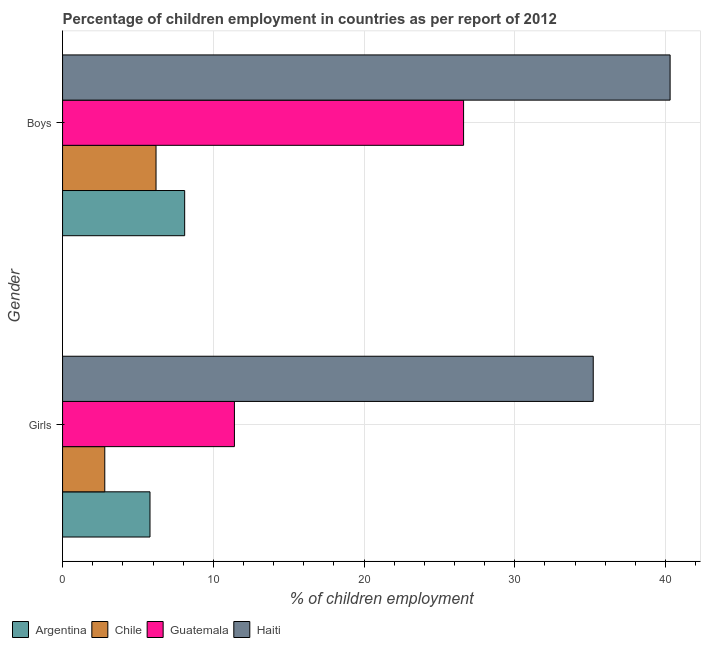How many groups of bars are there?
Make the answer very short. 2. Are the number of bars on each tick of the Y-axis equal?
Provide a succinct answer. Yes. How many bars are there on the 2nd tick from the top?
Your answer should be compact. 4. How many bars are there on the 1st tick from the bottom?
Make the answer very short. 4. What is the label of the 2nd group of bars from the top?
Keep it short and to the point. Girls. What is the percentage of employed girls in Chile?
Provide a succinct answer. 2.8. Across all countries, what is the maximum percentage of employed boys?
Offer a very short reply. 40.3. Across all countries, what is the minimum percentage of employed girls?
Your answer should be very brief. 2.8. In which country was the percentage of employed girls maximum?
Your answer should be compact. Haiti. What is the total percentage of employed girls in the graph?
Your response must be concise. 55.2. What is the difference between the percentage of employed boys in Haiti and that in Chile?
Your response must be concise. 34.1. What is the difference between the percentage of employed girls in Haiti and the percentage of employed boys in Chile?
Provide a short and direct response. 29. What is the difference between the percentage of employed boys and percentage of employed girls in Haiti?
Make the answer very short. 5.1. What is the ratio of the percentage of employed boys in Haiti to that in Argentina?
Offer a very short reply. 4.98. Is the percentage of employed girls in Argentina less than that in Haiti?
Your answer should be very brief. Yes. In how many countries, is the percentage of employed girls greater than the average percentage of employed girls taken over all countries?
Offer a terse response. 1. What does the 2nd bar from the top in Girls represents?
Provide a short and direct response. Guatemala. What does the 3rd bar from the bottom in Boys represents?
Provide a succinct answer. Guatemala. How many bars are there?
Offer a terse response. 8. Are all the bars in the graph horizontal?
Offer a terse response. Yes. Does the graph contain any zero values?
Provide a succinct answer. No. How many legend labels are there?
Your response must be concise. 4. How are the legend labels stacked?
Provide a short and direct response. Horizontal. What is the title of the graph?
Provide a short and direct response. Percentage of children employment in countries as per report of 2012. Does "Uganda" appear as one of the legend labels in the graph?
Provide a succinct answer. No. What is the label or title of the X-axis?
Keep it short and to the point. % of children employment. What is the label or title of the Y-axis?
Keep it short and to the point. Gender. What is the % of children employment in Chile in Girls?
Provide a succinct answer. 2.8. What is the % of children employment in Haiti in Girls?
Provide a succinct answer. 35.2. What is the % of children employment of Chile in Boys?
Your answer should be compact. 6.2. What is the % of children employment of Guatemala in Boys?
Give a very brief answer. 26.6. What is the % of children employment in Haiti in Boys?
Ensure brevity in your answer.  40.3. Across all Gender, what is the maximum % of children employment of Chile?
Provide a short and direct response. 6.2. Across all Gender, what is the maximum % of children employment of Guatemala?
Ensure brevity in your answer.  26.6. Across all Gender, what is the maximum % of children employment of Haiti?
Offer a terse response. 40.3. Across all Gender, what is the minimum % of children employment in Guatemala?
Give a very brief answer. 11.4. Across all Gender, what is the minimum % of children employment of Haiti?
Provide a short and direct response. 35.2. What is the total % of children employment of Argentina in the graph?
Give a very brief answer. 13.9. What is the total % of children employment in Chile in the graph?
Provide a succinct answer. 9. What is the total % of children employment of Haiti in the graph?
Keep it short and to the point. 75.5. What is the difference between the % of children employment in Chile in Girls and that in Boys?
Give a very brief answer. -3.4. What is the difference between the % of children employment of Guatemala in Girls and that in Boys?
Make the answer very short. -15.2. What is the difference between the % of children employment in Haiti in Girls and that in Boys?
Your answer should be very brief. -5.1. What is the difference between the % of children employment in Argentina in Girls and the % of children employment in Guatemala in Boys?
Your answer should be very brief. -20.8. What is the difference between the % of children employment in Argentina in Girls and the % of children employment in Haiti in Boys?
Keep it short and to the point. -34.5. What is the difference between the % of children employment of Chile in Girls and the % of children employment of Guatemala in Boys?
Keep it short and to the point. -23.8. What is the difference between the % of children employment in Chile in Girls and the % of children employment in Haiti in Boys?
Keep it short and to the point. -37.5. What is the difference between the % of children employment in Guatemala in Girls and the % of children employment in Haiti in Boys?
Your response must be concise. -28.9. What is the average % of children employment of Argentina per Gender?
Offer a terse response. 6.95. What is the average % of children employment of Chile per Gender?
Your answer should be compact. 4.5. What is the average % of children employment of Haiti per Gender?
Your response must be concise. 37.75. What is the difference between the % of children employment in Argentina and % of children employment in Haiti in Girls?
Give a very brief answer. -29.4. What is the difference between the % of children employment of Chile and % of children employment of Haiti in Girls?
Offer a terse response. -32.4. What is the difference between the % of children employment of Guatemala and % of children employment of Haiti in Girls?
Your answer should be very brief. -23.8. What is the difference between the % of children employment in Argentina and % of children employment in Guatemala in Boys?
Provide a short and direct response. -18.5. What is the difference between the % of children employment in Argentina and % of children employment in Haiti in Boys?
Your answer should be very brief. -32.2. What is the difference between the % of children employment of Chile and % of children employment of Guatemala in Boys?
Your response must be concise. -20.4. What is the difference between the % of children employment of Chile and % of children employment of Haiti in Boys?
Your answer should be compact. -34.1. What is the difference between the % of children employment in Guatemala and % of children employment in Haiti in Boys?
Give a very brief answer. -13.7. What is the ratio of the % of children employment of Argentina in Girls to that in Boys?
Keep it short and to the point. 0.72. What is the ratio of the % of children employment of Chile in Girls to that in Boys?
Give a very brief answer. 0.45. What is the ratio of the % of children employment of Guatemala in Girls to that in Boys?
Your answer should be very brief. 0.43. What is the ratio of the % of children employment of Haiti in Girls to that in Boys?
Your answer should be very brief. 0.87. What is the difference between the highest and the second highest % of children employment of Haiti?
Your response must be concise. 5.1. What is the difference between the highest and the lowest % of children employment of Argentina?
Your response must be concise. 2.3. What is the difference between the highest and the lowest % of children employment of Chile?
Your answer should be compact. 3.4. 